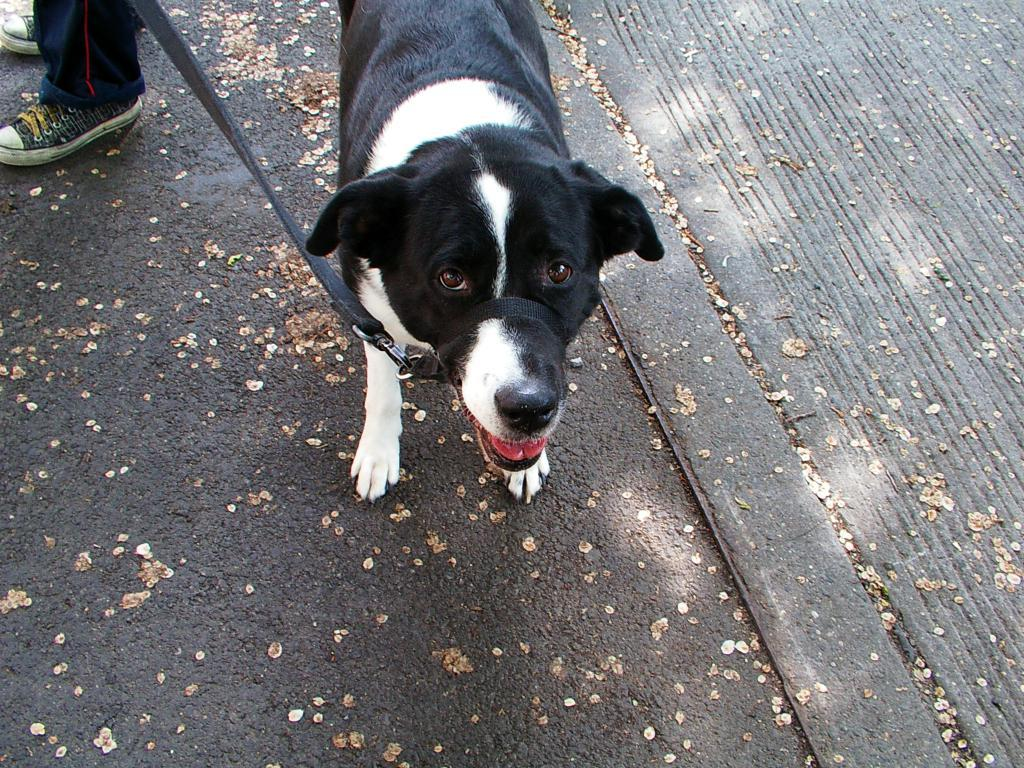What type of animal is present in the image? There is a dog in the image. What type of accessory is visible in the image? There is a black belt in the image. What type of footwear is present in the image? There are shoes in the image. What type of man-made structure can be seen in the image? The image contains a road. Where is the swing located in the image? There is no swing present in the image. How many houses can be seen in the image? There are no houses present in the image. 